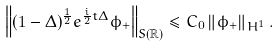<formula> <loc_0><loc_0><loc_500><loc_500>\left \| ( 1 - \Delta ) ^ { \frac { 1 } { 2 } } e ^ { \frac { i } { 2 } t \Delta } \phi _ { + } \right \| _ { S ( \mathbb { R } ) } \leq C _ { 0 } \left \| \phi _ { + } \right \| _ { H ^ { 1 } } .</formula> 